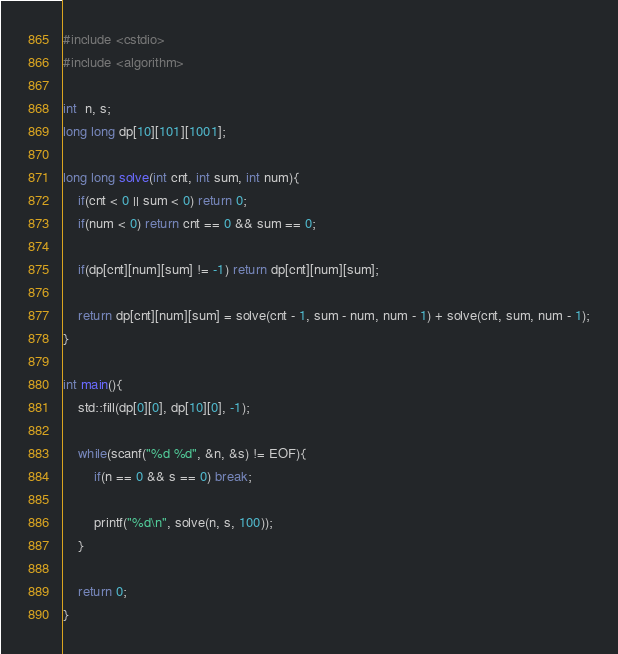Convert code to text. <code><loc_0><loc_0><loc_500><loc_500><_C++_>#include <cstdio>
#include <algorithm>

int  n, s;
long long dp[10][101][1001];

long long solve(int cnt, int sum, int num){
    if(cnt < 0 || sum < 0) return 0;
    if(num < 0) return cnt == 0 && sum == 0;

    if(dp[cnt][num][sum] != -1) return dp[cnt][num][sum];

    return dp[cnt][num][sum] = solve(cnt - 1, sum - num, num - 1) + solve(cnt, sum, num - 1);
}

int main(){
    std::fill(dp[0][0], dp[10][0], -1);

    while(scanf("%d %d", &n, &s) != EOF){
        if(n == 0 && s == 0) break;

        printf("%d\n", solve(n, s, 100));
    }

    return 0;
}</code> 